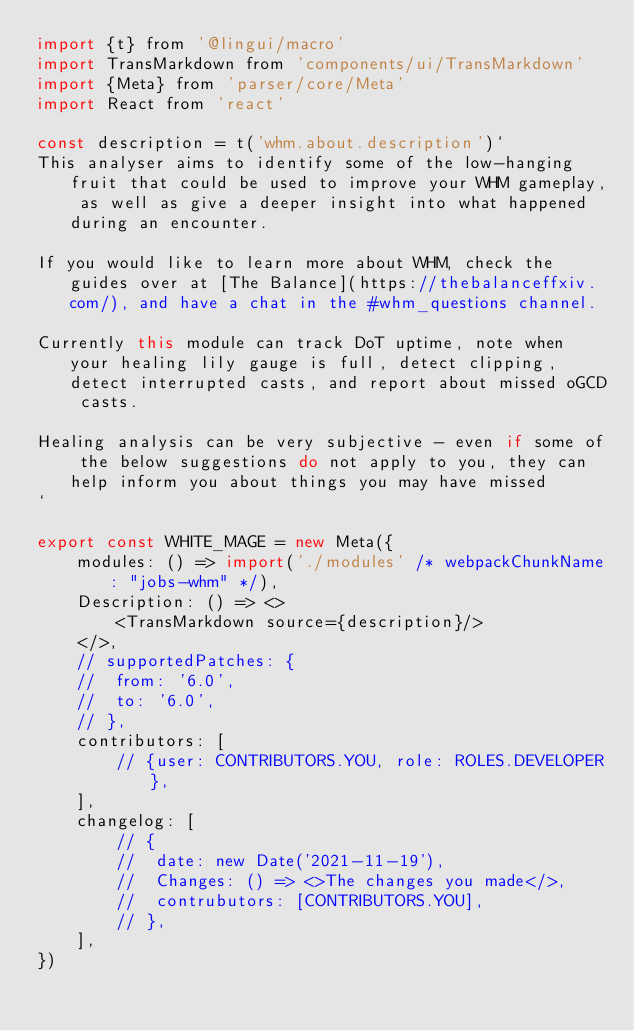Convert code to text. <code><loc_0><loc_0><loc_500><loc_500><_JavaScript_>import {t} from '@lingui/macro'
import TransMarkdown from 'components/ui/TransMarkdown'
import {Meta} from 'parser/core/Meta'
import React from 'react'

const description = t('whm.about.description')`
This analyser aims to identify some of the low-hanging fruit that could be used to improve your WHM gameplay, as well as give a deeper insight into what happened during an encounter.

If you would like to learn more about WHM, check the guides over at [The Balance](https://thebalanceffxiv.com/), and have a chat in the #whm_questions channel.

Currently this module can track DoT uptime, note when your healing lily gauge is full, detect clipping, detect interrupted casts, and report about missed oGCD casts.

Healing analysis can be very subjective - even if some of the below suggestions do not apply to you, they can help inform you about things you may have missed
`

export const WHITE_MAGE = new Meta({
	modules: () => import('./modules' /* webpackChunkName: "jobs-whm" */),
	Description: () => <>
		<TransMarkdown source={description}/>
	</>,
	// supportedPatches: {
	// 	from: '6.0',
	// 	to: '6.0',
	// },
	contributors: [
		// {user: CONTRIBUTORS.YOU, role: ROLES.DEVELOPER},
	],
	changelog: [
		// {
		// 	date: new Date('2021-11-19'),
		// 	Changes: () => <>The changes you made</>,
		// 	contrubutors: [CONTRIBUTORS.YOU],
		// },
	],
})
</code> 